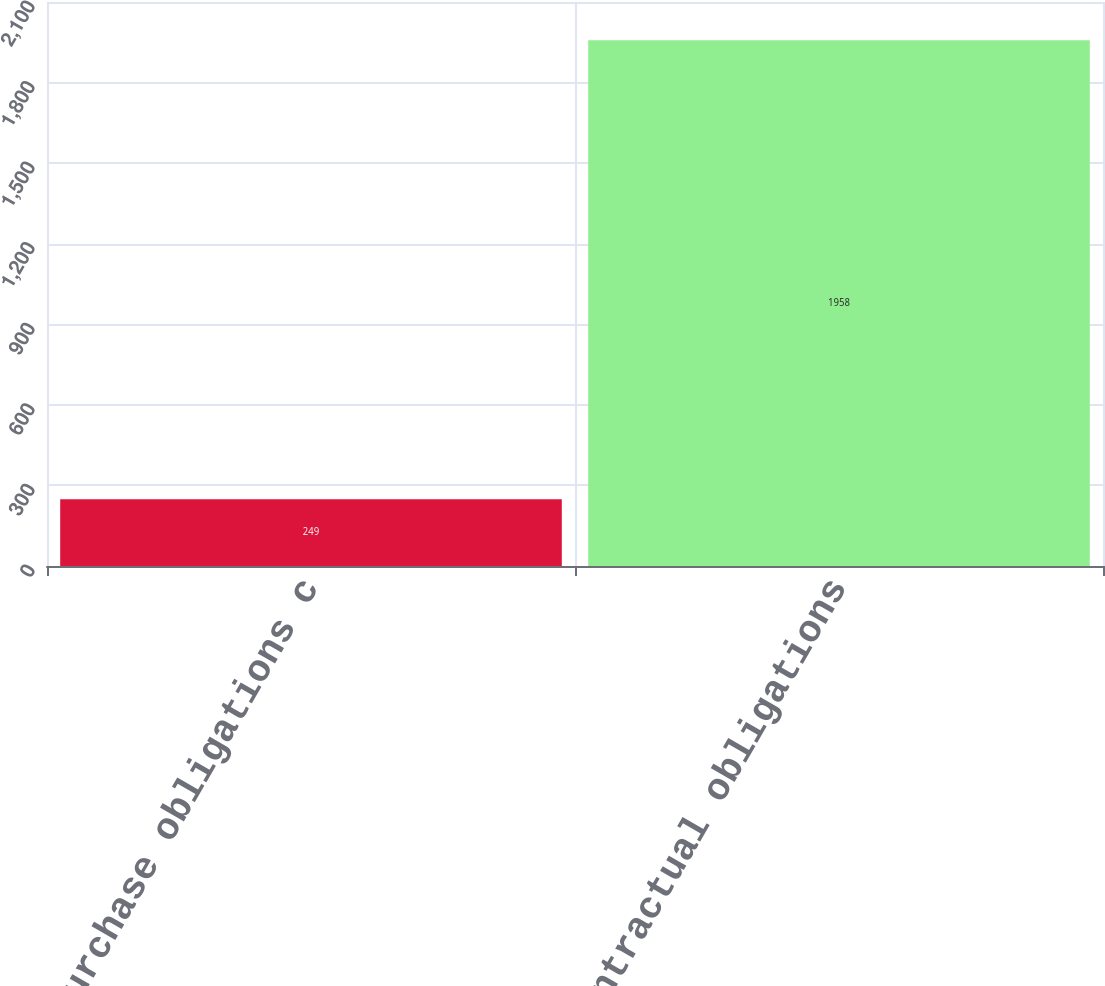<chart> <loc_0><loc_0><loc_500><loc_500><bar_chart><fcel>Purchase obligations c<fcel>Total contractual obligations<nl><fcel>249<fcel>1958<nl></chart> 